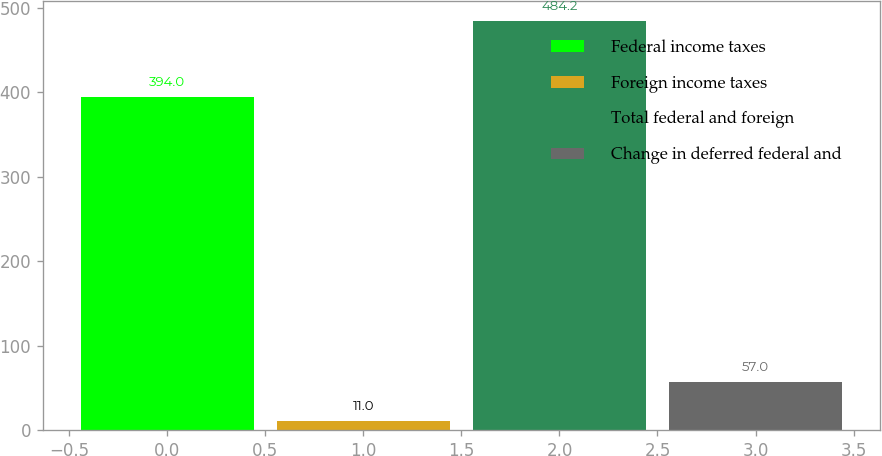Convert chart to OTSL. <chart><loc_0><loc_0><loc_500><loc_500><bar_chart><fcel>Federal income taxes<fcel>Foreign income taxes<fcel>Total federal and foreign<fcel>Change in deferred federal and<nl><fcel>394<fcel>11<fcel>484.2<fcel>57<nl></chart> 